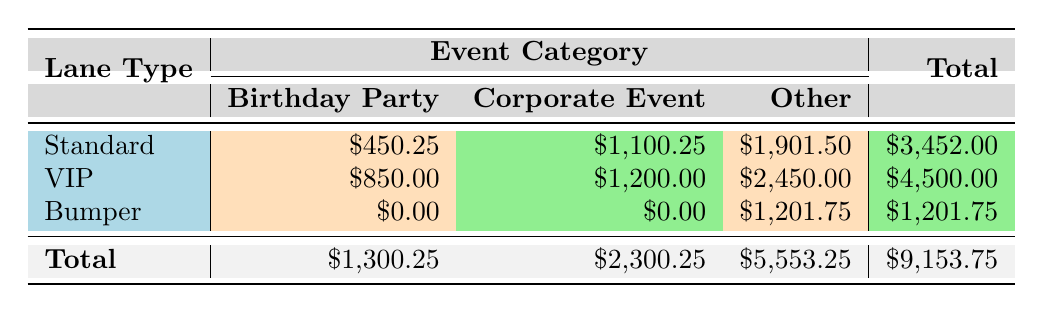What is the total revenue for Standard lane type? The total revenue for Standard lane type is calculated by adding the revenues from all event categories under this lane type: Birthday Party (450.25) + Corporate Event (1100.25) + Other (1901.50) = 3452.00.
Answer: 3452.00 How much revenue was generated from VIP lane type events? For VIP lane type, the revenue is calculated by adding Birthday Party (850.00), Corporate Event (1200.00), and Other (2450.00). So, the total is 850.00 + 1200.00 + 2450.00 = 4500.00.
Answer: 4500.00 Did Bumper lanes generate any revenue from Corporate Events? Looking at the table, Bumper lanes show a revenue of $0.00 for Corporate Events, indicating they did not generate any revenue from this category.
Answer: No What is the total revenue from all lane types for Birthday Parties? The total is calculated by summing the revenues from each lane type for Birthday Parties: Standard (450.25) + VIP (850.00) + Bumper (0.00) = 1300.25, giving a total of 1300.25.
Answer: 1300.25 Which lane type generated the highest revenue from the Other event category? The revenues from the Other category are: Standard (1901.50), VIP (2450.00), and Bumper (1201.75). VIP lanes generated the highest revenue of 2450.00 from this category.
Answer: VIP What is the average revenue per event category for Standard lane type? The average revenue is calculated by summing the revenues for each event category (Birthday Party 450.25 + Corporate Event 1100.25 + Other 1901.50) which totals to 3452.00 and dividing by the number of categories (3). Therefore, the average revenue is 3452.00 / 3 = 1150.67.
Answer: 1150.67 What is the difference in total revenue between Standard and VIP lanes? To find the difference, subtract total revenue of Standard (3452.00) from VIP (4500.00). So, the difference is 4500.00 - 3452.00 = 1048.00.
Answer: 1048.00 Is the total revenue from the Other category more than the combined revenue from Birthday Parties and Corporate Events? The total revenue from Other is 5553.25. The combined revenue from Birthday Parties (1300.25) and Corporate Events (2300.25) totals to 3600.50, which is less than 5553.25, so the condition is true.
Answer: Yes Which event category had the lowest revenue from Bumper lanes? The only revenue from Bumper lanes comes from the Other event category, which is 1201.75, as there are no other revenues listed for this lane type. Therefore, it's the only amount and the lowest.
Answer: Other 